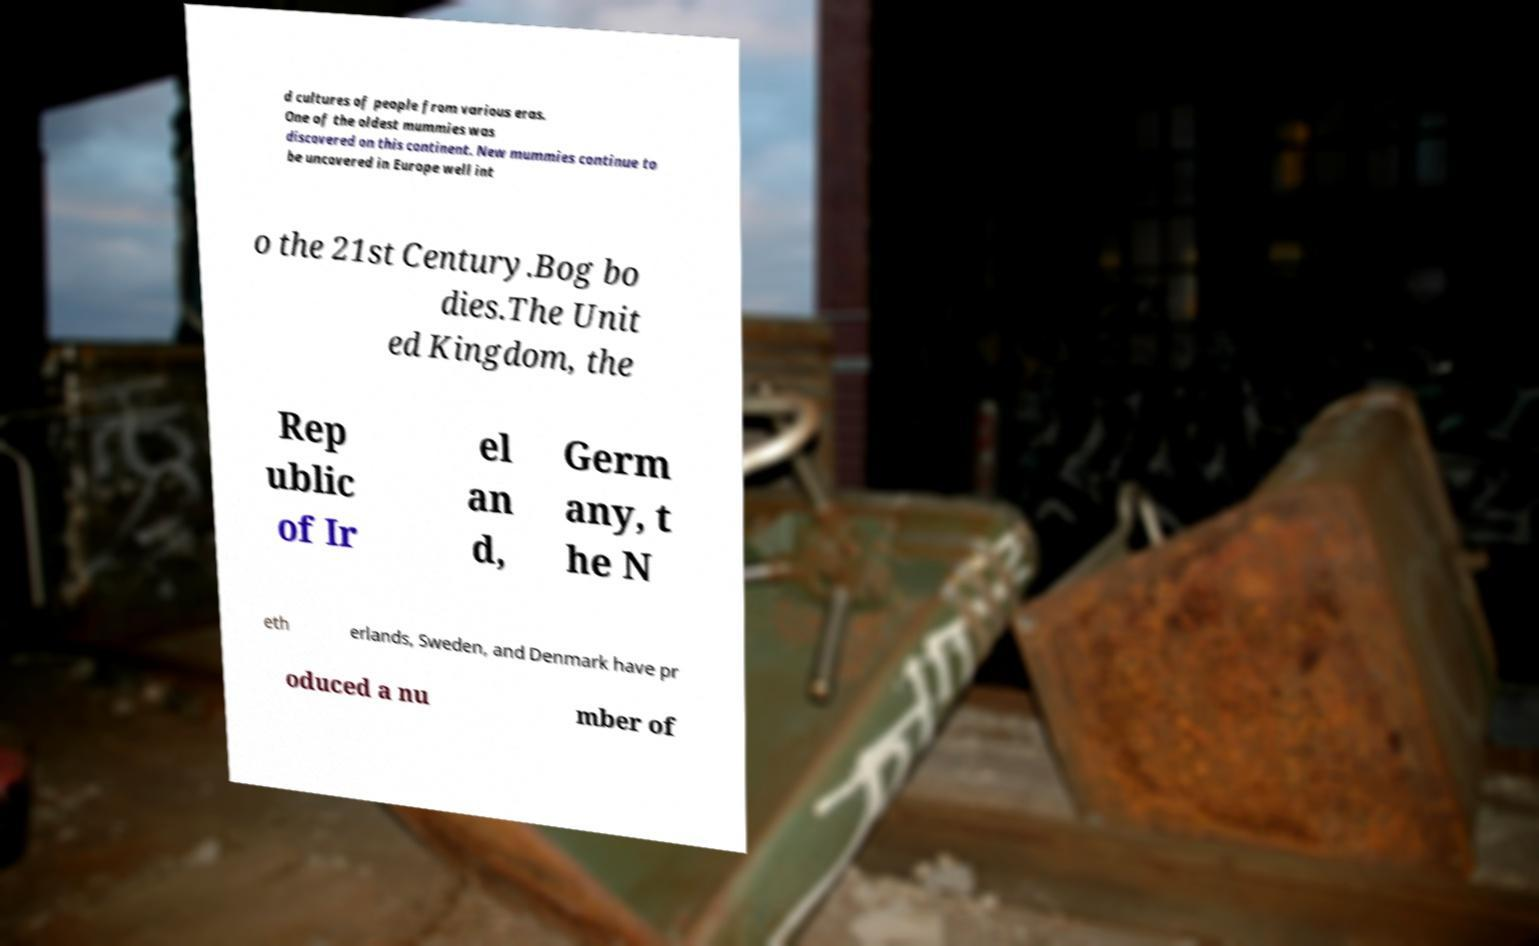What messages or text are displayed in this image? I need them in a readable, typed format. d cultures of people from various eras. One of the oldest mummies was discovered on this continent. New mummies continue to be uncovered in Europe well int o the 21st Century.Bog bo dies.The Unit ed Kingdom, the Rep ublic of Ir el an d, Germ any, t he N eth erlands, Sweden, and Denmark have pr oduced a nu mber of 